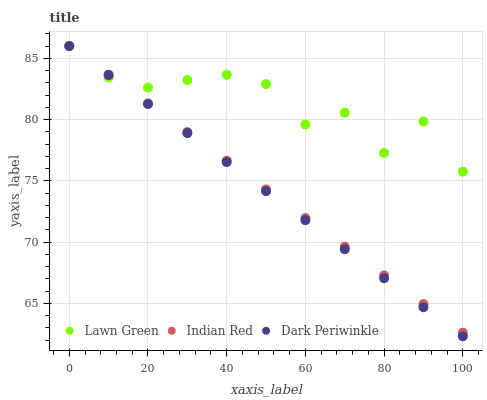Does Dark Periwinkle have the minimum area under the curve?
Answer yes or no. Yes. Does Lawn Green have the maximum area under the curve?
Answer yes or no. Yes. Does Indian Red have the minimum area under the curve?
Answer yes or no. No. Does Indian Red have the maximum area under the curve?
Answer yes or no. No. Is Dark Periwinkle the smoothest?
Answer yes or no. Yes. Is Lawn Green the roughest?
Answer yes or no. Yes. Is Indian Red the smoothest?
Answer yes or no. No. Is Indian Red the roughest?
Answer yes or no. No. Does Dark Periwinkle have the lowest value?
Answer yes or no. Yes. Does Indian Red have the lowest value?
Answer yes or no. No. Does Indian Red have the highest value?
Answer yes or no. Yes. Does Dark Periwinkle intersect Indian Red?
Answer yes or no. Yes. Is Dark Periwinkle less than Indian Red?
Answer yes or no. No. Is Dark Periwinkle greater than Indian Red?
Answer yes or no. No. 